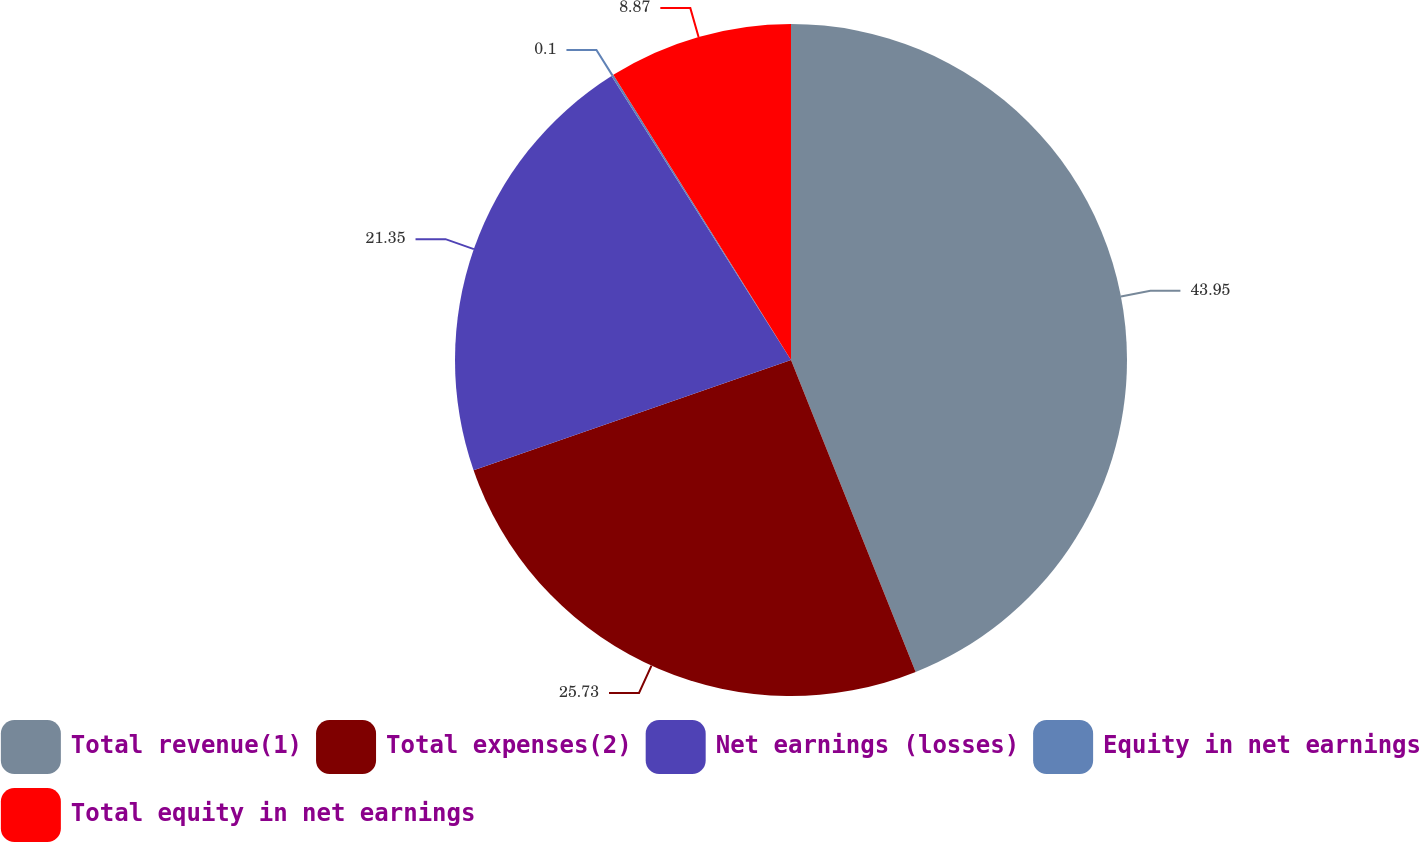<chart> <loc_0><loc_0><loc_500><loc_500><pie_chart><fcel>Total revenue(1)<fcel>Total expenses(2)<fcel>Net earnings (losses)<fcel>Equity in net earnings<fcel>Total equity in net earnings<nl><fcel>43.95%<fcel>25.73%<fcel>21.35%<fcel>0.1%<fcel>8.87%<nl></chart> 